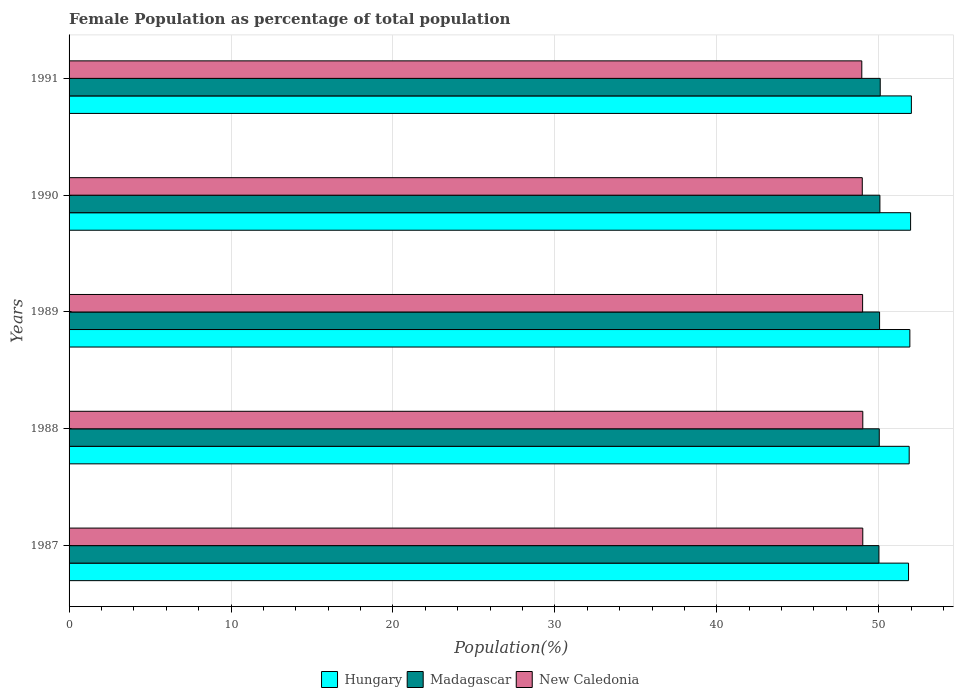How many groups of bars are there?
Make the answer very short. 5. Are the number of bars per tick equal to the number of legend labels?
Provide a succinct answer. Yes. How many bars are there on the 5th tick from the top?
Ensure brevity in your answer.  3. How many bars are there on the 5th tick from the bottom?
Provide a succinct answer. 3. What is the label of the 5th group of bars from the top?
Your answer should be compact. 1987. What is the female population in in Hungary in 1990?
Provide a succinct answer. 51.97. Across all years, what is the maximum female population in in Madagascar?
Provide a succinct answer. 50.09. Across all years, what is the minimum female population in in Madagascar?
Keep it short and to the point. 50.01. In which year was the female population in in New Caledonia maximum?
Offer a very short reply. 1988. What is the total female population in in Hungary in the graph?
Your response must be concise. 259.62. What is the difference between the female population in in Hungary in 1989 and that in 1991?
Offer a terse response. -0.09. What is the difference between the female population in in Hungary in 1990 and the female population in in New Caledonia in 1988?
Ensure brevity in your answer.  2.95. What is the average female population in in Hungary per year?
Your answer should be very brief. 51.92. In the year 1988, what is the difference between the female population in in Hungary and female population in in Madagascar?
Offer a terse response. 1.85. What is the ratio of the female population in in New Caledonia in 1988 to that in 1991?
Keep it short and to the point. 1. What is the difference between the highest and the second highest female population in in Madagascar?
Keep it short and to the point. 0.02. What is the difference between the highest and the lowest female population in in New Caledonia?
Ensure brevity in your answer.  0.06. In how many years, is the female population in in Madagascar greater than the average female population in in Madagascar taken over all years?
Give a very brief answer. 2. Is the sum of the female population in in Madagascar in 1988 and 1989 greater than the maximum female population in in New Caledonia across all years?
Give a very brief answer. Yes. What does the 1st bar from the top in 1988 represents?
Provide a succinct answer. New Caledonia. What does the 3rd bar from the bottom in 1989 represents?
Provide a short and direct response. New Caledonia. Is it the case that in every year, the sum of the female population in in New Caledonia and female population in in Hungary is greater than the female population in in Madagascar?
Keep it short and to the point. Yes. How many bars are there?
Offer a terse response. 15. Are all the bars in the graph horizontal?
Keep it short and to the point. Yes. How many years are there in the graph?
Make the answer very short. 5. Does the graph contain any zero values?
Your answer should be very brief. No. Does the graph contain grids?
Offer a terse response. Yes. Where does the legend appear in the graph?
Your answer should be compact. Bottom center. What is the title of the graph?
Your response must be concise. Female Population as percentage of total population. What is the label or title of the X-axis?
Your response must be concise. Population(%). What is the label or title of the Y-axis?
Your answer should be very brief. Years. What is the Population(%) of Hungary in 1987?
Ensure brevity in your answer.  51.84. What is the Population(%) in Madagascar in 1987?
Give a very brief answer. 50.01. What is the Population(%) in New Caledonia in 1987?
Provide a succinct answer. 49.01. What is the Population(%) in Hungary in 1988?
Keep it short and to the point. 51.88. What is the Population(%) in Madagascar in 1988?
Make the answer very short. 50.03. What is the Population(%) of New Caledonia in 1988?
Give a very brief answer. 49.01. What is the Population(%) in Hungary in 1989?
Give a very brief answer. 51.92. What is the Population(%) of Madagascar in 1989?
Your answer should be very brief. 50.05. What is the Population(%) in New Caledonia in 1989?
Give a very brief answer. 49. What is the Population(%) in Hungary in 1990?
Offer a very short reply. 51.97. What is the Population(%) of Madagascar in 1990?
Give a very brief answer. 50.07. What is the Population(%) of New Caledonia in 1990?
Your answer should be very brief. 48.98. What is the Population(%) in Hungary in 1991?
Make the answer very short. 52.02. What is the Population(%) of Madagascar in 1991?
Ensure brevity in your answer.  50.09. What is the Population(%) of New Caledonia in 1991?
Make the answer very short. 48.95. Across all years, what is the maximum Population(%) in Hungary?
Give a very brief answer. 52.02. Across all years, what is the maximum Population(%) in Madagascar?
Offer a terse response. 50.09. Across all years, what is the maximum Population(%) of New Caledonia?
Give a very brief answer. 49.01. Across all years, what is the minimum Population(%) in Hungary?
Ensure brevity in your answer.  51.84. Across all years, what is the minimum Population(%) in Madagascar?
Give a very brief answer. 50.01. Across all years, what is the minimum Population(%) in New Caledonia?
Make the answer very short. 48.95. What is the total Population(%) of Hungary in the graph?
Your response must be concise. 259.62. What is the total Population(%) in Madagascar in the graph?
Keep it short and to the point. 250.26. What is the total Population(%) of New Caledonia in the graph?
Offer a very short reply. 244.97. What is the difference between the Population(%) in Hungary in 1987 and that in 1988?
Give a very brief answer. -0.04. What is the difference between the Population(%) of Madagascar in 1987 and that in 1988?
Provide a succinct answer. -0.02. What is the difference between the Population(%) of New Caledonia in 1987 and that in 1988?
Offer a terse response. -0. What is the difference between the Population(%) in Hungary in 1987 and that in 1989?
Ensure brevity in your answer.  -0.08. What is the difference between the Population(%) of Madagascar in 1987 and that in 1989?
Your response must be concise. -0.04. What is the difference between the Population(%) of New Caledonia in 1987 and that in 1989?
Provide a succinct answer. 0.01. What is the difference between the Population(%) in Hungary in 1987 and that in 1990?
Keep it short and to the point. -0.13. What is the difference between the Population(%) of Madagascar in 1987 and that in 1990?
Provide a short and direct response. -0.06. What is the difference between the Population(%) in New Caledonia in 1987 and that in 1990?
Your answer should be compact. 0.03. What is the difference between the Population(%) in Hungary in 1987 and that in 1991?
Keep it short and to the point. -0.17. What is the difference between the Population(%) of Madagascar in 1987 and that in 1991?
Your answer should be very brief. -0.08. What is the difference between the Population(%) of New Caledonia in 1987 and that in 1991?
Offer a terse response. 0.06. What is the difference between the Population(%) of Hungary in 1988 and that in 1989?
Keep it short and to the point. -0.04. What is the difference between the Population(%) of Madagascar in 1988 and that in 1989?
Your answer should be very brief. -0.02. What is the difference between the Population(%) of New Caledonia in 1988 and that in 1989?
Your answer should be very brief. 0.01. What is the difference between the Population(%) of Hungary in 1988 and that in 1990?
Keep it short and to the point. -0.09. What is the difference between the Population(%) in Madagascar in 1988 and that in 1990?
Offer a terse response. -0.04. What is the difference between the Population(%) of New Caledonia in 1988 and that in 1990?
Keep it short and to the point. 0.03. What is the difference between the Population(%) of Hungary in 1988 and that in 1991?
Your answer should be very brief. -0.13. What is the difference between the Population(%) of Madagascar in 1988 and that in 1991?
Your answer should be compact. -0.06. What is the difference between the Population(%) in New Caledonia in 1988 and that in 1991?
Offer a terse response. 0.06. What is the difference between the Population(%) of Hungary in 1989 and that in 1990?
Offer a very short reply. -0.04. What is the difference between the Population(%) of Madagascar in 1989 and that in 1990?
Keep it short and to the point. -0.02. What is the difference between the Population(%) in New Caledonia in 1989 and that in 1990?
Ensure brevity in your answer.  0.02. What is the difference between the Population(%) of Hungary in 1989 and that in 1991?
Make the answer very short. -0.09. What is the difference between the Population(%) in Madagascar in 1989 and that in 1991?
Offer a terse response. -0.04. What is the difference between the Population(%) of New Caledonia in 1989 and that in 1991?
Your answer should be compact. 0.05. What is the difference between the Population(%) of Hungary in 1990 and that in 1991?
Your response must be concise. -0.05. What is the difference between the Population(%) in Madagascar in 1990 and that in 1991?
Provide a succinct answer. -0.02. What is the difference between the Population(%) in New Caledonia in 1990 and that in 1991?
Keep it short and to the point. 0.03. What is the difference between the Population(%) in Hungary in 1987 and the Population(%) in Madagascar in 1988?
Offer a very short reply. 1.81. What is the difference between the Population(%) in Hungary in 1987 and the Population(%) in New Caledonia in 1988?
Keep it short and to the point. 2.83. What is the difference between the Population(%) in Madagascar in 1987 and the Population(%) in New Caledonia in 1988?
Keep it short and to the point. 1. What is the difference between the Population(%) in Hungary in 1987 and the Population(%) in Madagascar in 1989?
Provide a succinct answer. 1.79. What is the difference between the Population(%) in Hungary in 1987 and the Population(%) in New Caledonia in 1989?
Make the answer very short. 2.84. What is the difference between the Population(%) of Madagascar in 1987 and the Population(%) of New Caledonia in 1989?
Provide a succinct answer. 1.01. What is the difference between the Population(%) of Hungary in 1987 and the Population(%) of Madagascar in 1990?
Offer a terse response. 1.77. What is the difference between the Population(%) in Hungary in 1987 and the Population(%) in New Caledonia in 1990?
Give a very brief answer. 2.86. What is the difference between the Population(%) in Madagascar in 1987 and the Population(%) in New Caledonia in 1990?
Give a very brief answer. 1.03. What is the difference between the Population(%) of Hungary in 1987 and the Population(%) of Madagascar in 1991?
Provide a short and direct response. 1.75. What is the difference between the Population(%) in Hungary in 1987 and the Population(%) in New Caledonia in 1991?
Offer a terse response. 2.89. What is the difference between the Population(%) of Madagascar in 1987 and the Population(%) of New Caledonia in 1991?
Provide a succinct answer. 1.06. What is the difference between the Population(%) in Hungary in 1988 and the Population(%) in Madagascar in 1989?
Provide a succinct answer. 1.83. What is the difference between the Population(%) in Hungary in 1988 and the Population(%) in New Caledonia in 1989?
Give a very brief answer. 2.88. What is the difference between the Population(%) of Madagascar in 1988 and the Population(%) of New Caledonia in 1989?
Keep it short and to the point. 1.03. What is the difference between the Population(%) in Hungary in 1988 and the Population(%) in Madagascar in 1990?
Ensure brevity in your answer.  1.81. What is the difference between the Population(%) of Hungary in 1988 and the Population(%) of New Caledonia in 1990?
Your answer should be compact. 2.9. What is the difference between the Population(%) in Madagascar in 1988 and the Population(%) in New Caledonia in 1990?
Provide a succinct answer. 1.05. What is the difference between the Population(%) of Hungary in 1988 and the Population(%) of Madagascar in 1991?
Offer a terse response. 1.79. What is the difference between the Population(%) of Hungary in 1988 and the Population(%) of New Caledonia in 1991?
Your answer should be compact. 2.93. What is the difference between the Population(%) of Madagascar in 1988 and the Population(%) of New Caledonia in 1991?
Keep it short and to the point. 1.08. What is the difference between the Population(%) in Hungary in 1989 and the Population(%) in Madagascar in 1990?
Ensure brevity in your answer.  1.85. What is the difference between the Population(%) of Hungary in 1989 and the Population(%) of New Caledonia in 1990?
Provide a short and direct response. 2.94. What is the difference between the Population(%) of Madagascar in 1989 and the Population(%) of New Caledonia in 1990?
Provide a short and direct response. 1.07. What is the difference between the Population(%) in Hungary in 1989 and the Population(%) in Madagascar in 1991?
Your answer should be very brief. 1.83. What is the difference between the Population(%) of Hungary in 1989 and the Population(%) of New Caledonia in 1991?
Provide a succinct answer. 2.97. What is the difference between the Population(%) of Madagascar in 1989 and the Population(%) of New Caledonia in 1991?
Your answer should be very brief. 1.1. What is the difference between the Population(%) of Hungary in 1990 and the Population(%) of Madagascar in 1991?
Offer a terse response. 1.87. What is the difference between the Population(%) of Hungary in 1990 and the Population(%) of New Caledonia in 1991?
Your response must be concise. 3.01. What is the difference between the Population(%) in Madagascar in 1990 and the Population(%) in New Caledonia in 1991?
Give a very brief answer. 1.12. What is the average Population(%) of Hungary per year?
Your answer should be compact. 51.92. What is the average Population(%) of Madagascar per year?
Give a very brief answer. 50.05. What is the average Population(%) of New Caledonia per year?
Your response must be concise. 48.99. In the year 1987, what is the difference between the Population(%) of Hungary and Population(%) of Madagascar?
Make the answer very short. 1.83. In the year 1987, what is the difference between the Population(%) in Hungary and Population(%) in New Caledonia?
Offer a terse response. 2.83. In the year 1988, what is the difference between the Population(%) of Hungary and Population(%) of Madagascar?
Ensure brevity in your answer.  1.85. In the year 1988, what is the difference between the Population(%) in Hungary and Population(%) in New Caledonia?
Offer a terse response. 2.87. In the year 1988, what is the difference between the Population(%) of Madagascar and Population(%) of New Caledonia?
Provide a short and direct response. 1.02. In the year 1989, what is the difference between the Population(%) in Hungary and Population(%) in Madagascar?
Make the answer very short. 1.87. In the year 1989, what is the difference between the Population(%) in Hungary and Population(%) in New Caledonia?
Ensure brevity in your answer.  2.92. In the year 1989, what is the difference between the Population(%) of Madagascar and Population(%) of New Caledonia?
Keep it short and to the point. 1.05. In the year 1990, what is the difference between the Population(%) of Hungary and Population(%) of Madagascar?
Offer a terse response. 1.89. In the year 1990, what is the difference between the Population(%) of Hungary and Population(%) of New Caledonia?
Keep it short and to the point. 2.98. In the year 1990, what is the difference between the Population(%) in Madagascar and Population(%) in New Caledonia?
Offer a very short reply. 1.09. In the year 1991, what is the difference between the Population(%) of Hungary and Population(%) of Madagascar?
Make the answer very short. 1.92. In the year 1991, what is the difference between the Population(%) of Hungary and Population(%) of New Caledonia?
Provide a succinct answer. 3.06. In the year 1991, what is the difference between the Population(%) of Madagascar and Population(%) of New Caledonia?
Provide a short and direct response. 1.14. What is the ratio of the Population(%) of Hungary in 1987 to that in 1988?
Ensure brevity in your answer.  1. What is the ratio of the Population(%) of New Caledonia in 1987 to that in 1988?
Ensure brevity in your answer.  1. What is the ratio of the Population(%) in Hungary in 1987 to that in 1989?
Offer a very short reply. 1. What is the ratio of the Population(%) of Hungary in 1987 to that in 1990?
Give a very brief answer. 1. What is the ratio of the Population(%) of Hungary in 1987 to that in 1991?
Your answer should be very brief. 1. What is the ratio of the Population(%) in Madagascar in 1987 to that in 1991?
Offer a very short reply. 1. What is the ratio of the Population(%) in New Caledonia in 1987 to that in 1991?
Ensure brevity in your answer.  1. What is the ratio of the Population(%) in Madagascar in 1988 to that in 1989?
Make the answer very short. 1. What is the ratio of the Population(%) in Hungary in 1988 to that in 1991?
Provide a short and direct response. 1. What is the ratio of the Population(%) in Madagascar in 1988 to that in 1991?
Offer a terse response. 1. What is the ratio of the Population(%) in New Caledonia in 1988 to that in 1991?
Ensure brevity in your answer.  1. What is the ratio of the Population(%) in Hungary in 1989 to that in 1990?
Provide a short and direct response. 1. What is the ratio of the Population(%) in New Caledonia in 1989 to that in 1990?
Keep it short and to the point. 1. What is the ratio of the Population(%) in Hungary in 1989 to that in 1991?
Give a very brief answer. 1. What is the difference between the highest and the second highest Population(%) of Hungary?
Your answer should be compact. 0.05. What is the difference between the highest and the second highest Population(%) in Madagascar?
Make the answer very short. 0.02. What is the difference between the highest and the second highest Population(%) of New Caledonia?
Your response must be concise. 0. What is the difference between the highest and the lowest Population(%) of Hungary?
Offer a very short reply. 0.17. What is the difference between the highest and the lowest Population(%) of Madagascar?
Your response must be concise. 0.08. What is the difference between the highest and the lowest Population(%) of New Caledonia?
Keep it short and to the point. 0.06. 